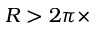<formula> <loc_0><loc_0><loc_500><loc_500>R > 2 \pi \times</formula> 